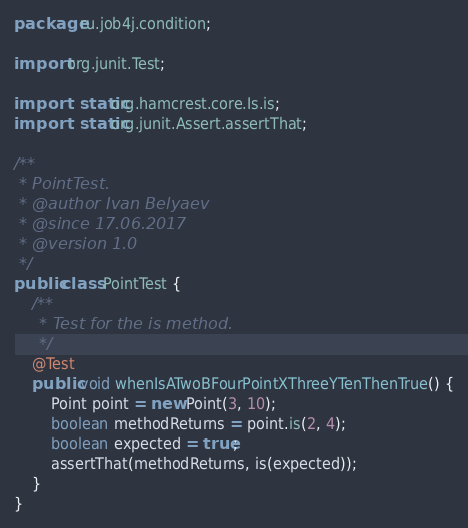<code> <loc_0><loc_0><loc_500><loc_500><_Java_>package ru.job4j.condition;

import org.junit.Test;

import static org.hamcrest.core.Is.is;
import static org.junit.Assert.assertThat;

/**
 * PointTest.
 * @author Ivan Belyaev
 * @since 17.06.2017
 * @version 1.0
 */
public class PointTest {
	/**
	 * Test for the is method.
	 */
	@Test
	public void whenIsATwoBFourPointXThreeYTenThenTrue() {
		Point point = new Point(3, 10);
		boolean methodReturns = point.is(2, 4);
		boolean expected = true;
		assertThat(methodReturns, is(expected));
	}
}
</code> 